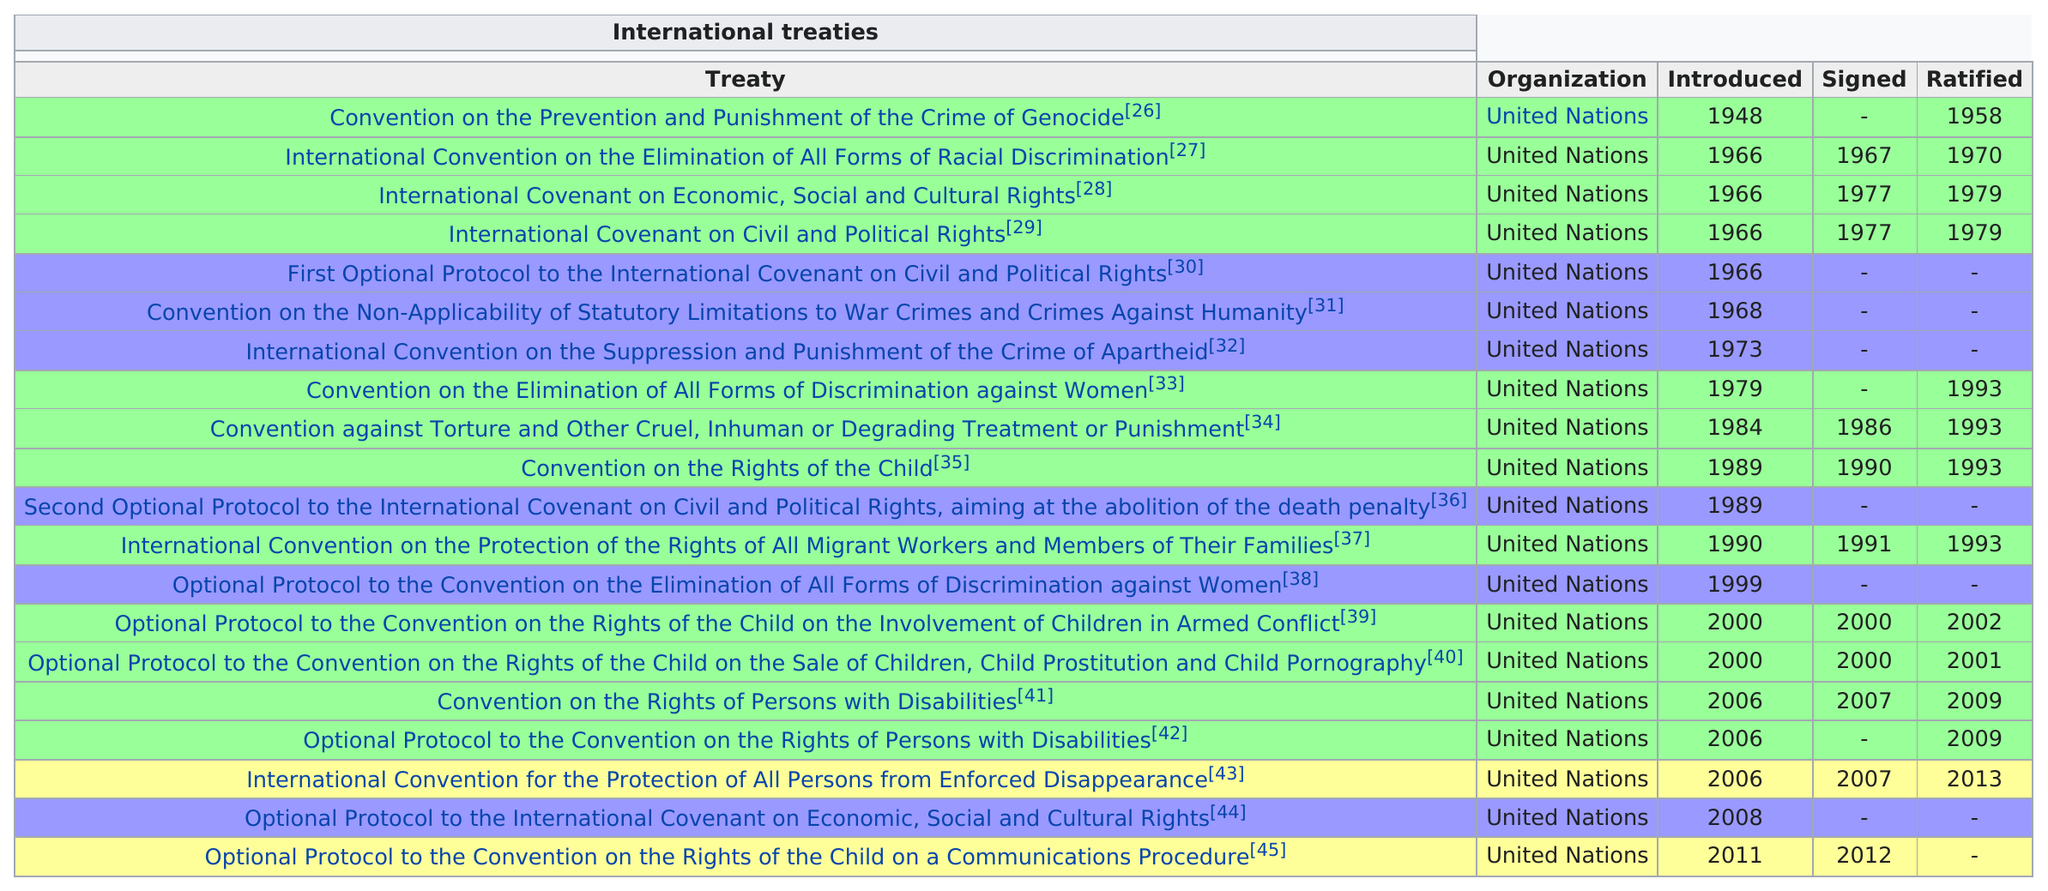Specify some key components in this picture. The International Covenant on Civil and Political Rights was ratified after being signed for a period of 11 years. The Convention on the Prevention and Punishment of the Crime of Genocide was the first treaty in Morocco to be ratified. Monaco has ratified at most four international human rights treaties in one year. Morocco signed the International Convention on the Elimination of All Forms of Racial Discrimination, which is considered as one of the earliest treaties signed by the country. In 1993, Monaco ratified more international human rights treaties than it did in 1979. 